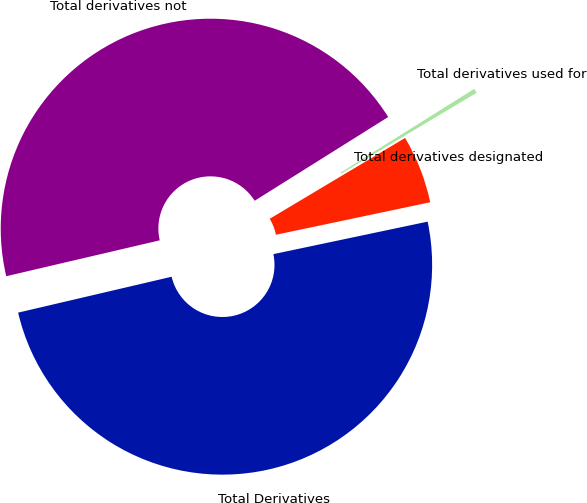Convert chart. <chart><loc_0><loc_0><loc_500><loc_500><pie_chart><fcel>Total derivatives designated<fcel>Total derivatives used for<fcel>Total derivatives not<fcel>Total Derivatives<nl><fcel>5.26%<fcel>0.35%<fcel>44.74%<fcel>49.65%<nl></chart> 